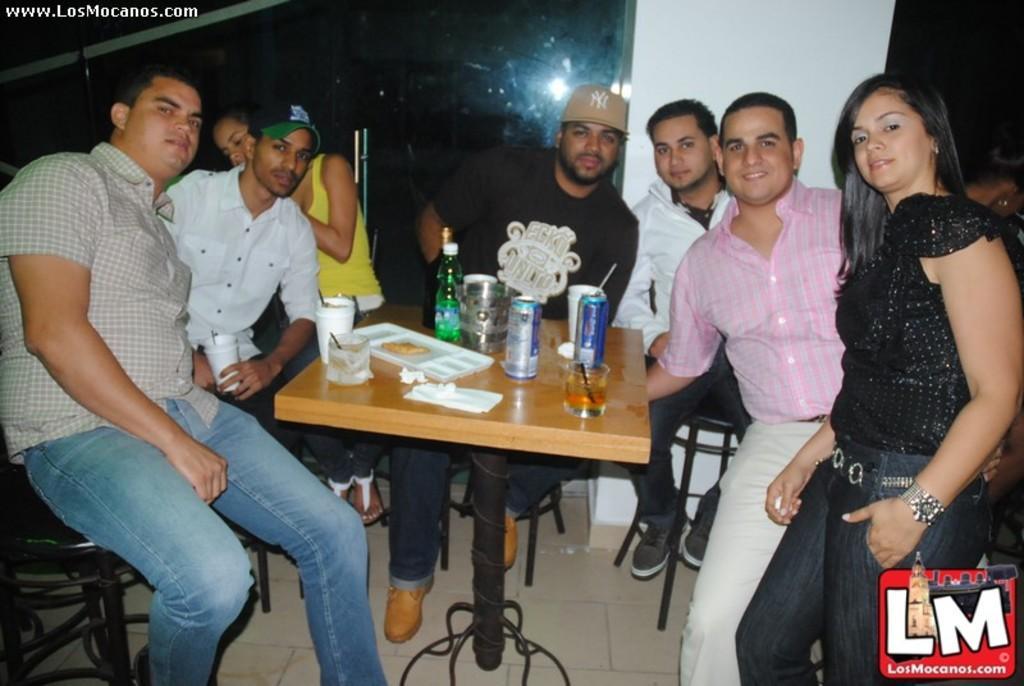Could you give a brief overview of what you see in this image? In this picture we can see a group of people siting on chairs and in front of them on table we have bottles, tins, glass with drink in it, trays and in background we can see pillar, wall. 